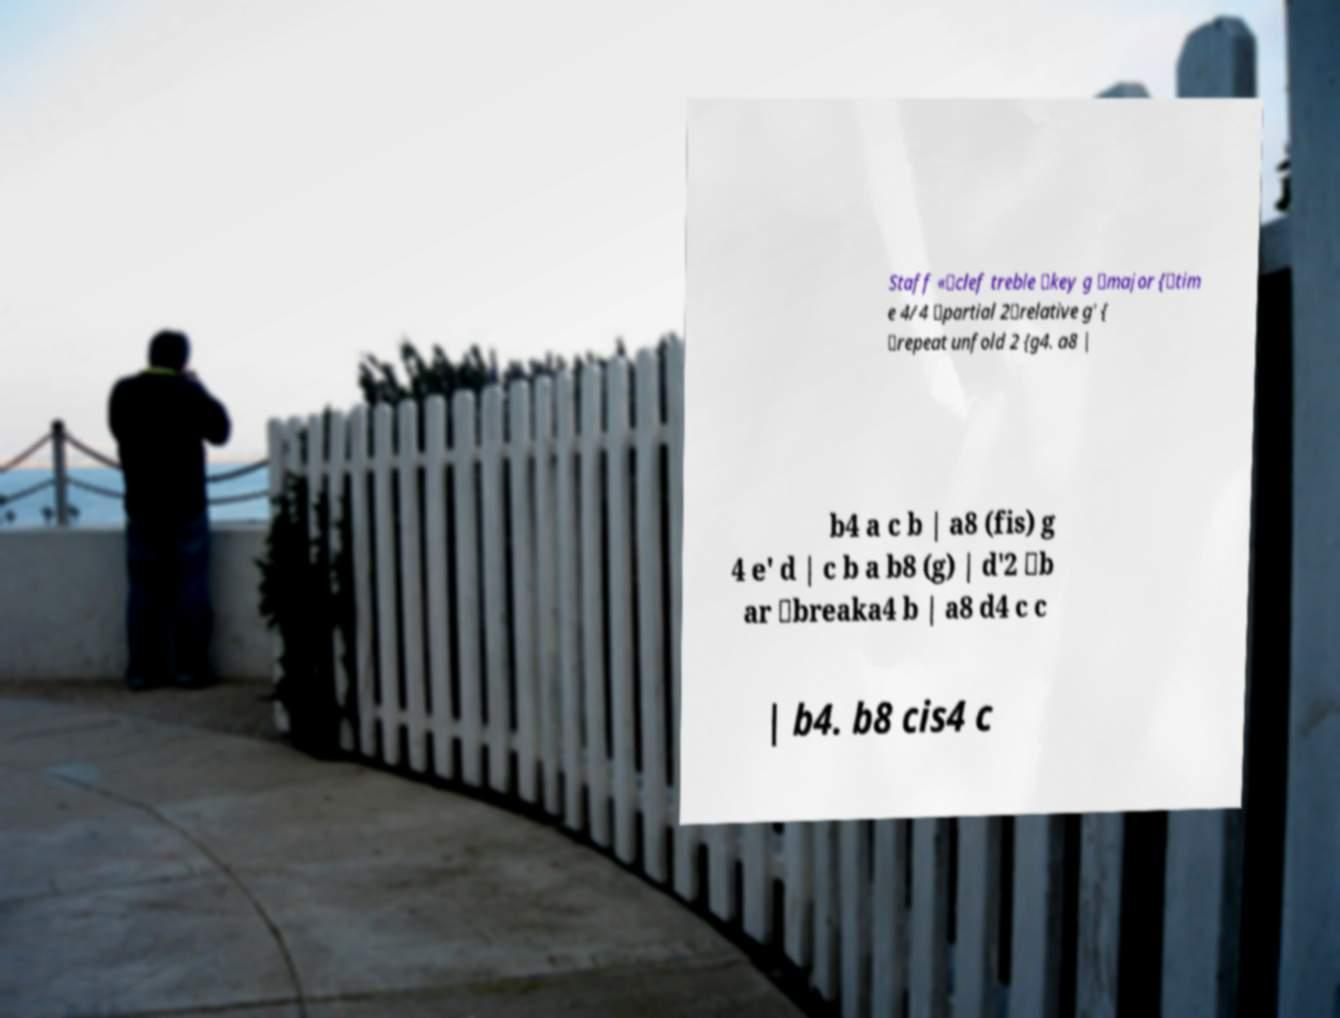Please identify and transcribe the text found in this image. Staff «\clef treble \key g \major {\tim e 4/4 \partial 2\relative g' { \repeat unfold 2 {g4. a8 | b4 a c b | a8 (fis) g 4 e' d | c b a b8 (g) | d'2 \b ar \breaka4 b | a8 d4 c c | b4. b8 cis4 c 